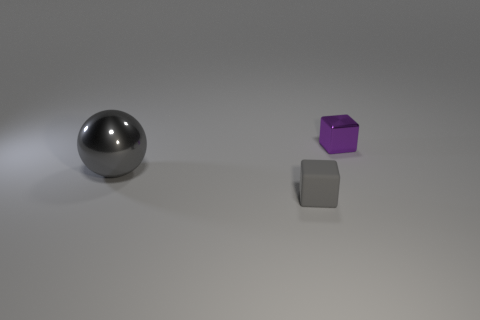Add 2 gray balls. How many objects exist? 5 Subtract all blocks. How many objects are left? 1 Subtract 0 cyan cubes. How many objects are left? 3 Subtract all green spheres. Subtract all purple cubes. How many spheres are left? 1 Subtract all shiny objects. Subtract all tiny gray cubes. How many objects are left? 0 Add 1 purple things. How many purple things are left? 2 Add 3 big yellow things. How many big yellow things exist? 3 